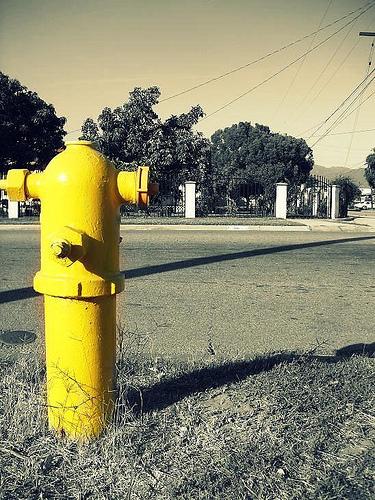Is there any cars on the road?
Keep it brief. No. What color is the hydrant?
Short answer required. Yellow. If there was a fire, could this hydrant be used easily by the firefighters?
Be succinct. Yes. 